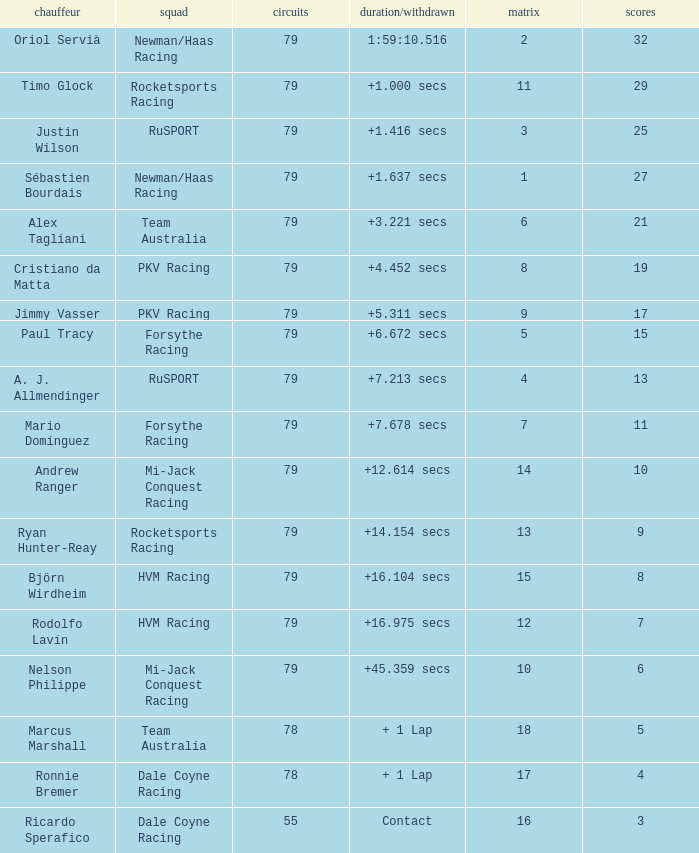Which points has the driver Paul Tracy? 15.0. 